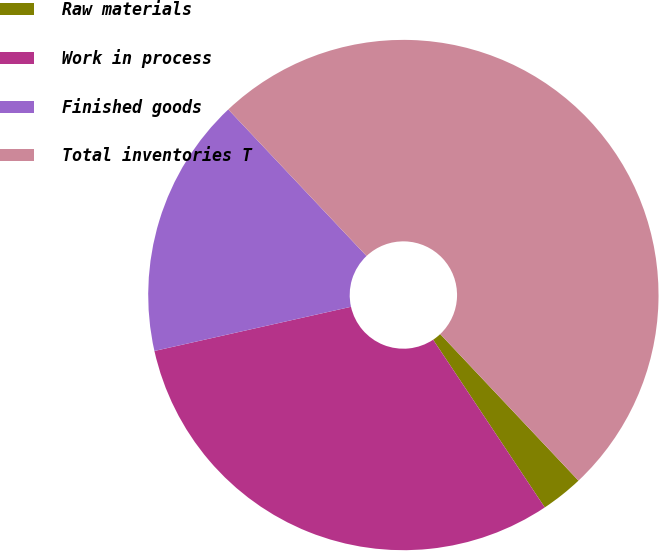Convert chart. <chart><loc_0><loc_0><loc_500><loc_500><pie_chart><fcel>Raw materials<fcel>Work in process<fcel>Finished goods<fcel>Total inventories T<nl><fcel>2.69%<fcel>30.83%<fcel>16.48%<fcel>50.0%<nl></chart> 